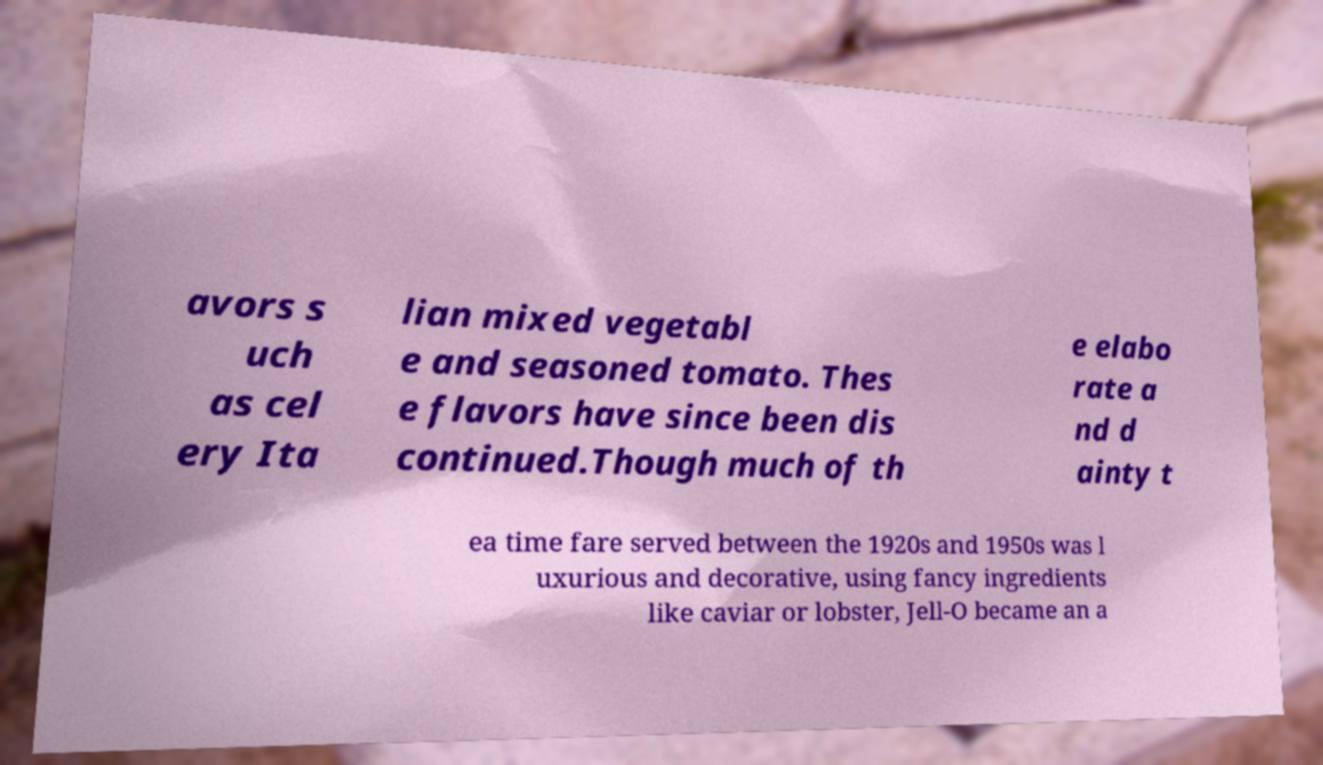Can you accurately transcribe the text from the provided image for me? avors s uch as cel ery Ita lian mixed vegetabl e and seasoned tomato. Thes e flavors have since been dis continued.Though much of th e elabo rate a nd d ainty t ea time fare served between the 1920s and 1950s was l uxurious and decorative, using fancy ingredients like caviar or lobster, Jell-O became an a 